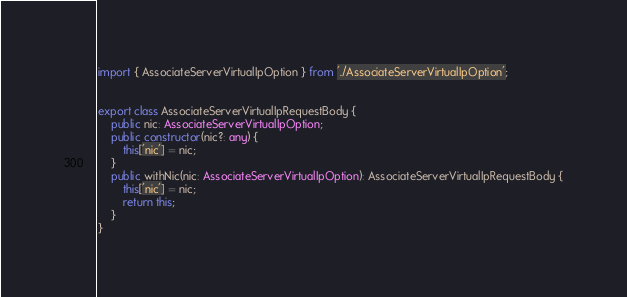<code> <loc_0><loc_0><loc_500><loc_500><_TypeScript_>import { AssociateServerVirtualIpOption } from './AssociateServerVirtualIpOption';


export class AssociateServerVirtualIpRequestBody {
    public nic: AssociateServerVirtualIpOption;
    public constructor(nic?: any) { 
        this['nic'] = nic;
    }
    public withNic(nic: AssociateServerVirtualIpOption): AssociateServerVirtualIpRequestBody {
        this['nic'] = nic;
        return this;
    }
}</code> 